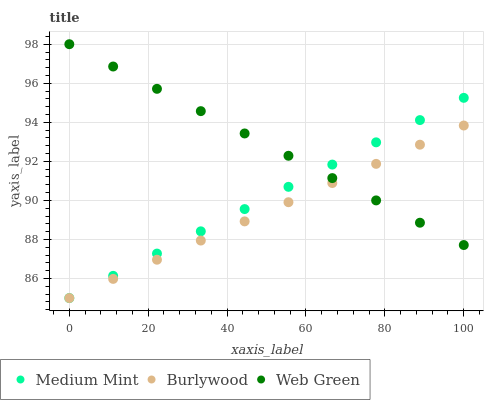Does Burlywood have the minimum area under the curve?
Answer yes or no. Yes. Does Web Green have the maximum area under the curve?
Answer yes or no. Yes. Does Web Green have the minimum area under the curve?
Answer yes or no. No. Does Burlywood have the maximum area under the curve?
Answer yes or no. No. Is Burlywood the smoothest?
Answer yes or no. Yes. Is Web Green the roughest?
Answer yes or no. Yes. Is Web Green the smoothest?
Answer yes or no. No. Is Burlywood the roughest?
Answer yes or no. No. Does Medium Mint have the lowest value?
Answer yes or no. Yes. Does Web Green have the lowest value?
Answer yes or no. No. Does Web Green have the highest value?
Answer yes or no. Yes. Does Burlywood have the highest value?
Answer yes or no. No. Does Web Green intersect Medium Mint?
Answer yes or no. Yes. Is Web Green less than Medium Mint?
Answer yes or no. No. Is Web Green greater than Medium Mint?
Answer yes or no. No. 